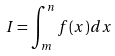<formula> <loc_0><loc_0><loc_500><loc_500>I = \int _ { m } ^ { n } f ( x ) d x</formula> 